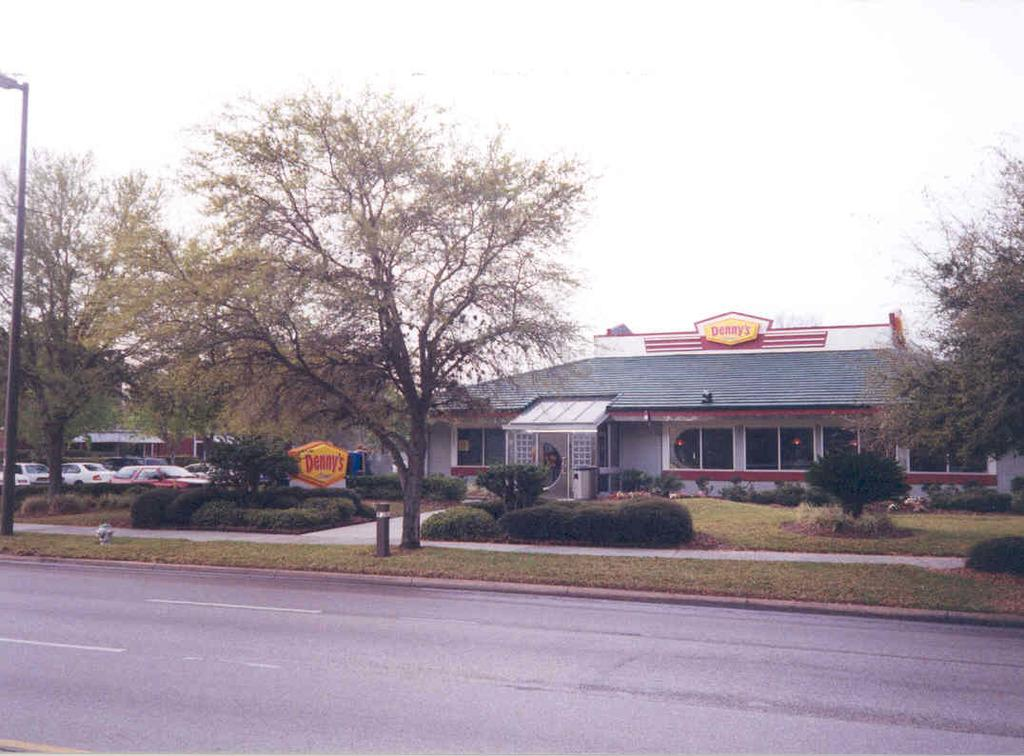What type of vegetation can be seen in the image? There are trees and plants in the image. What type of structures are present in the image? There are houses in the image. What type of transportation is visible in the image? There are vehicles in the image. What type of ground surface is present in the image? There is grass in the image. What type of vertical structures can be seen in the image? There are poles in the image. What type of surface is used for transportation in the image? There is a road in the image. What can be seen in the background of the image? The sky is visible in the background of the image. How many badges are hanging on the trees in the image? There are no badges present in the image. What type of fabric is draped over the plants in the image? There is no fabric draped over the plants in the image. How many oranges are visible on the road in the image? There are no oranges present in the image. 